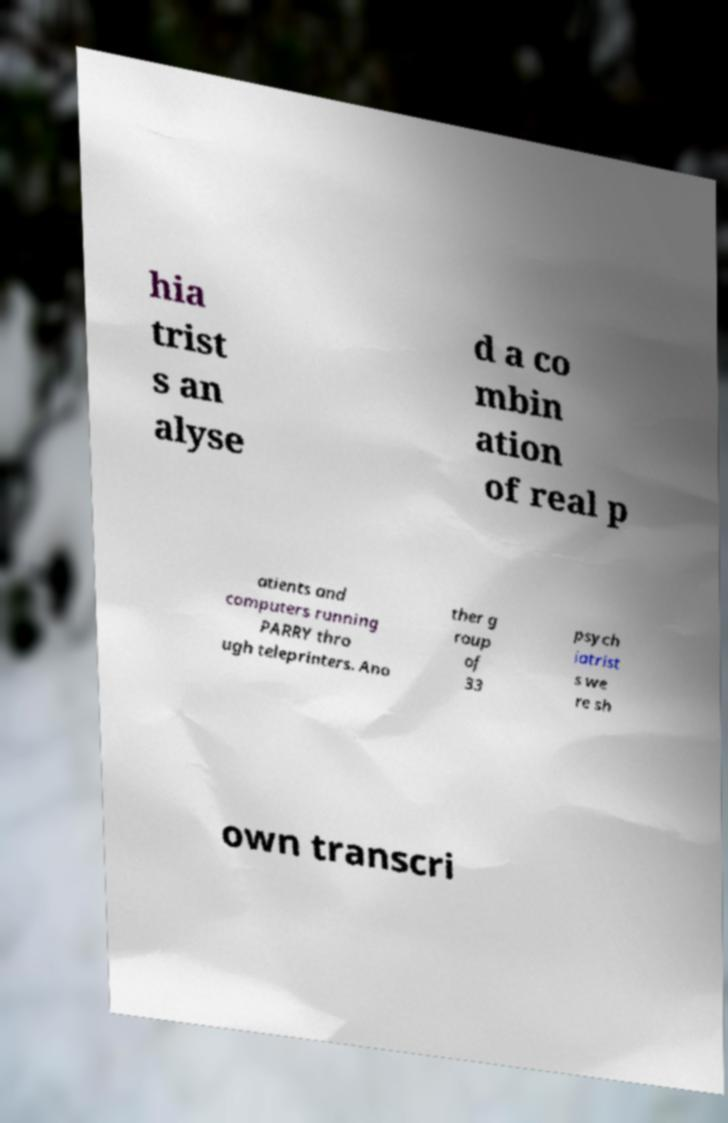For documentation purposes, I need the text within this image transcribed. Could you provide that? hia trist s an alyse d a co mbin ation of real p atients and computers running PARRY thro ugh teleprinters. Ano ther g roup of 33 psych iatrist s we re sh own transcri 